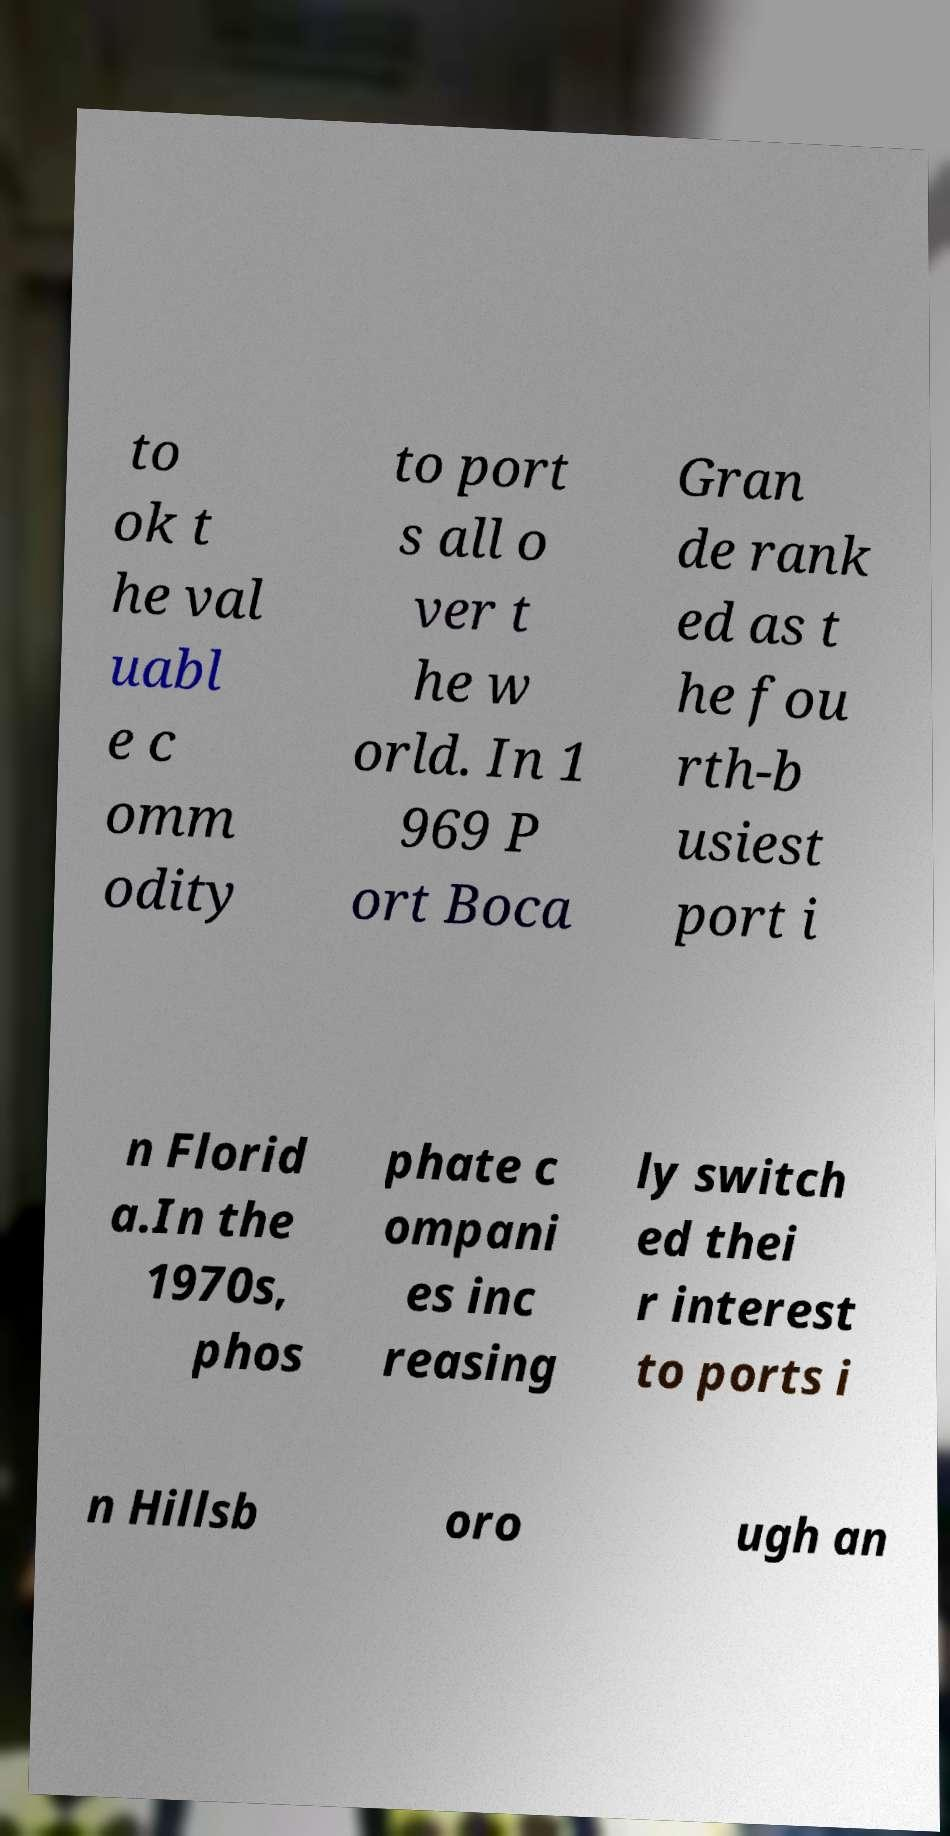There's text embedded in this image that I need extracted. Can you transcribe it verbatim? to ok t he val uabl e c omm odity to port s all o ver t he w orld. In 1 969 P ort Boca Gran de rank ed as t he fou rth-b usiest port i n Florid a.In the 1970s, phos phate c ompani es inc reasing ly switch ed thei r interest to ports i n Hillsb oro ugh an 